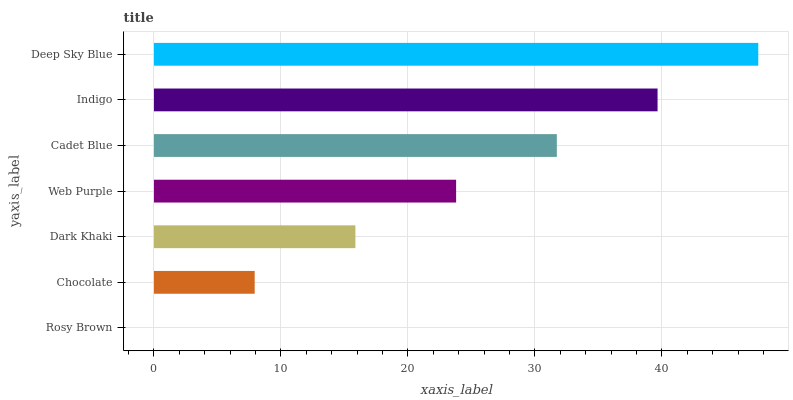Is Rosy Brown the minimum?
Answer yes or no. Yes. Is Deep Sky Blue the maximum?
Answer yes or no. Yes. Is Chocolate the minimum?
Answer yes or no. No. Is Chocolate the maximum?
Answer yes or no. No. Is Chocolate greater than Rosy Brown?
Answer yes or no. Yes. Is Rosy Brown less than Chocolate?
Answer yes or no. Yes. Is Rosy Brown greater than Chocolate?
Answer yes or no. No. Is Chocolate less than Rosy Brown?
Answer yes or no. No. Is Web Purple the high median?
Answer yes or no. Yes. Is Web Purple the low median?
Answer yes or no. Yes. Is Rosy Brown the high median?
Answer yes or no. No. Is Indigo the low median?
Answer yes or no. No. 